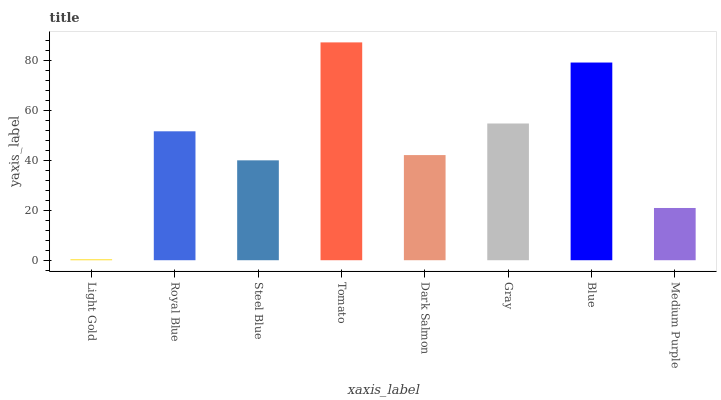Is Light Gold the minimum?
Answer yes or no. Yes. Is Tomato the maximum?
Answer yes or no. Yes. Is Royal Blue the minimum?
Answer yes or no. No. Is Royal Blue the maximum?
Answer yes or no. No. Is Royal Blue greater than Light Gold?
Answer yes or no. Yes. Is Light Gold less than Royal Blue?
Answer yes or no. Yes. Is Light Gold greater than Royal Blue?
Answer yes or no. No. Is Royal Blue less than Light Gold?
Answer yes or no. No. Is Royal Blue the high median?
Answer yes or no. Yes. Is Dark Salmon the low median?
Answer yes or no. Yes. Is Light Gold the high median?
Answer yes or no. No. Is Royal Blue the low median?
Answer yes or no. No. 